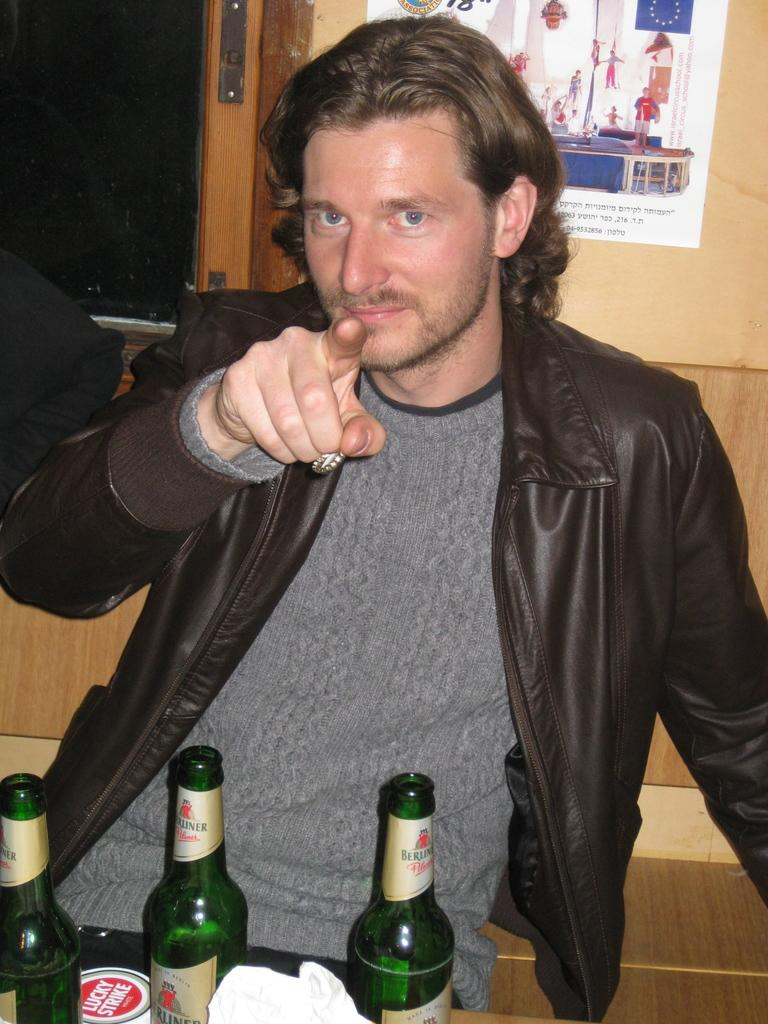Who is present in the image? There is a man in the image. What is the man doing with his finger? The man is pointing his finger. What can be seen on the table in the image? There are three wine bottles on a table in the image. What type of cap is the man wearing in the image? The man is not wearing a cap in the image. What is the man's interest in the wine bottles? The image does not provide information about the man's interest in the wine bottles. 